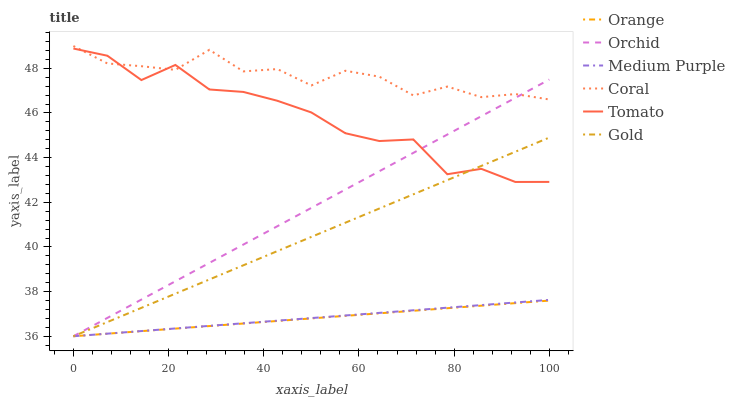Does Orange have the minimum area under the curve?
Answer yes or no. Yes. Does Coral have the maximum area under the curve?
Answer yes or no. Yes. Does Gold have the minimum area under the curve?
Answer yes or no. No. Does Gold have the maximum area under the curve?
Answer yes or no. No. Is Medium Purple the smoothest?
Answer yes or no. Yes. Is Tomato the roughest?
Answer yes or no. Yes. Is Gold the smoothest?
Answer yes or no. No. Is Gold the roughest?
Answer yes or no. No. Does Gold have the lowest value?
Answer yes or no. Yes. Does Coral have the lowest value?
Answer yes or no. No. Does Coral have the highest value?
Answer yes or no. Yes. Does Gold have the highest value?
Answer yes or no. No. Is Gold less than Coral?
Answer yes or no. Yes. Is Coral greater than Medium Purple?
Answer yes or no. Yes. Does Gold intersect Tomato?
Answer yes or no. Yes. Is Gold less than Tomato?
Answer yes or no. No. Is Gold greater than Tomato?
Answer yes or no. No. Does Gold intersect Coral?
Answer yes or no. No. 